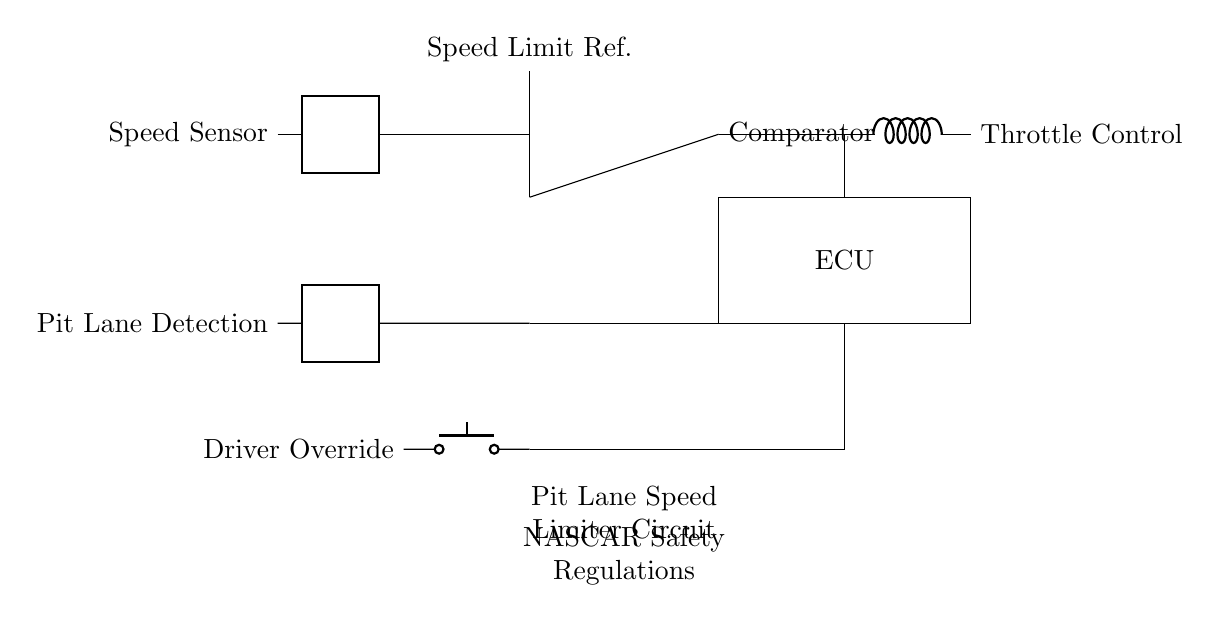What component detects speed in the circuit? The component that detects speed is the Speed Sensor, located at the left side of the circuit.
Answer: Speed Sensor What is the function of the comparator in this circuit? The comparator compares the speed from the Speed Sensor with the Speed Limit Reference to control throttle.
Answer: Throttle control How does the driver override feature function? The Driver Override is connected to a push button that allows the driver to manually control the throttle, bypassing the automatic speed limiter.
Answer: Manual control Which component is responsible for processing signals in the circuit? The component responsible for processing signals is the ECU, which receives input from the speed sensor and determines the throttle control action.
Answer: ECU What is the purpose of the pit lane detection? The Pit Lane Detection identifies when the vehicle is in the pit lane and communicates with the ECU to activate the speed limiter.
Answer: Activates speed limiter What happens if the speed exceeds the reference value? If the speed exceeds the reference value, the comparator sends a signal to reduce throttle control, enforcing the pit lane speed limit.
Answer: Reduces throttle control How is the throttle control implemented in this circuit? The throttle control is implemented using a cute inductor connected to the output of the comparator, regulating the engine's throttle accordingly.
Answer: Regulates engine throttle 